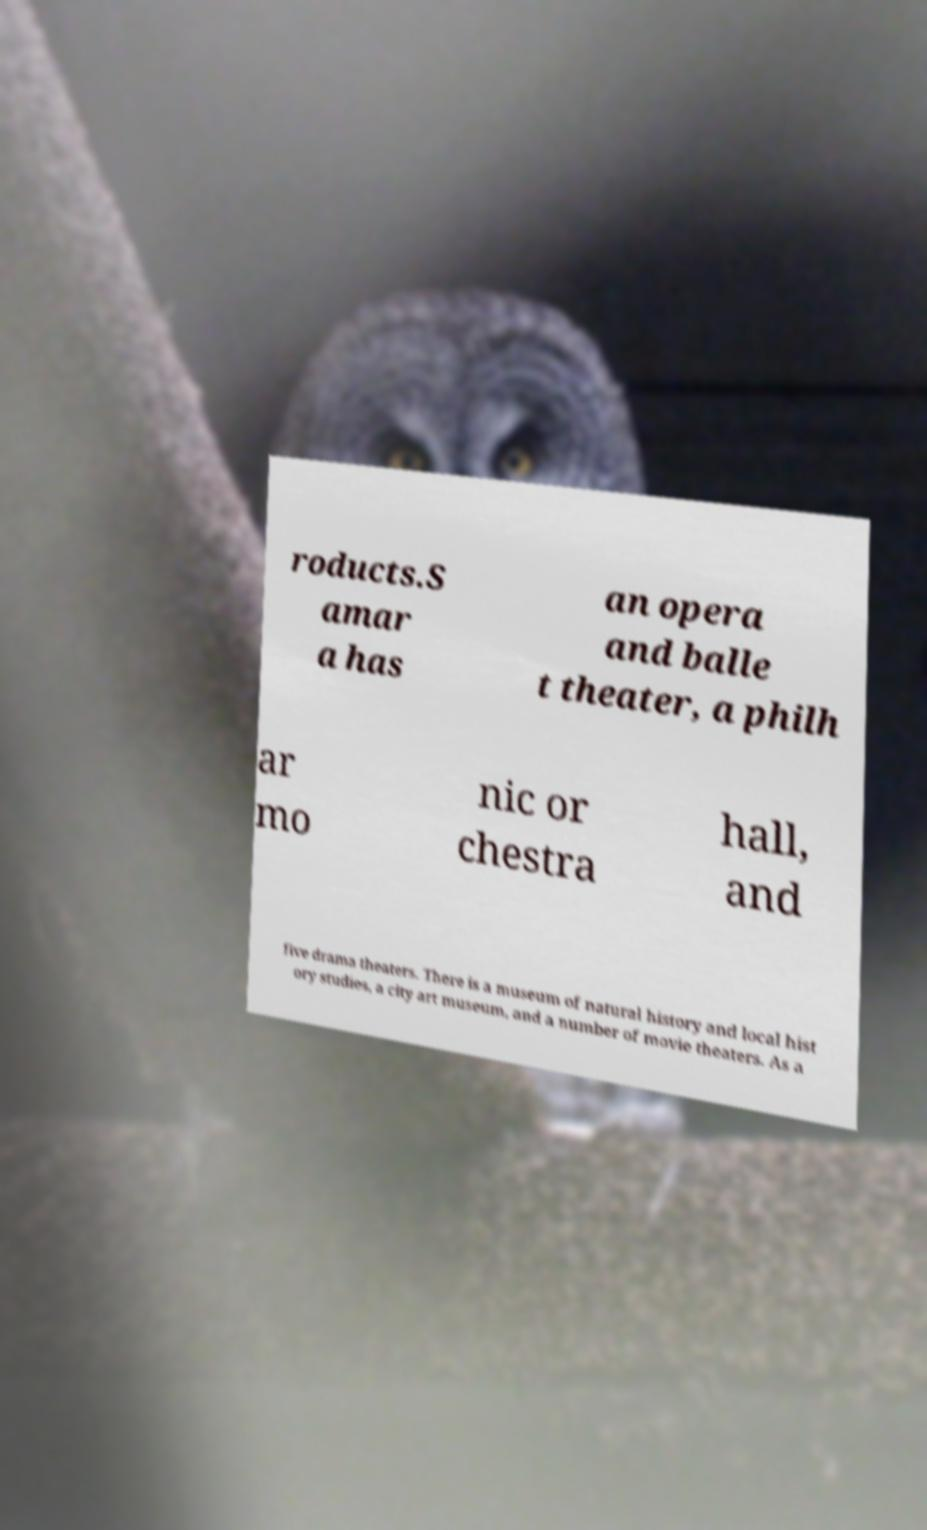For documentation purposes, I need the text within this image transcribed. Could you provide that? roducts.S amar a has an opera and balle t theater, a philh ar mo nic or chestra hall, and five drama theaters. There is a museum of natural history and local hist ory studies, a city art museum, and a number of movie theaters. As a 